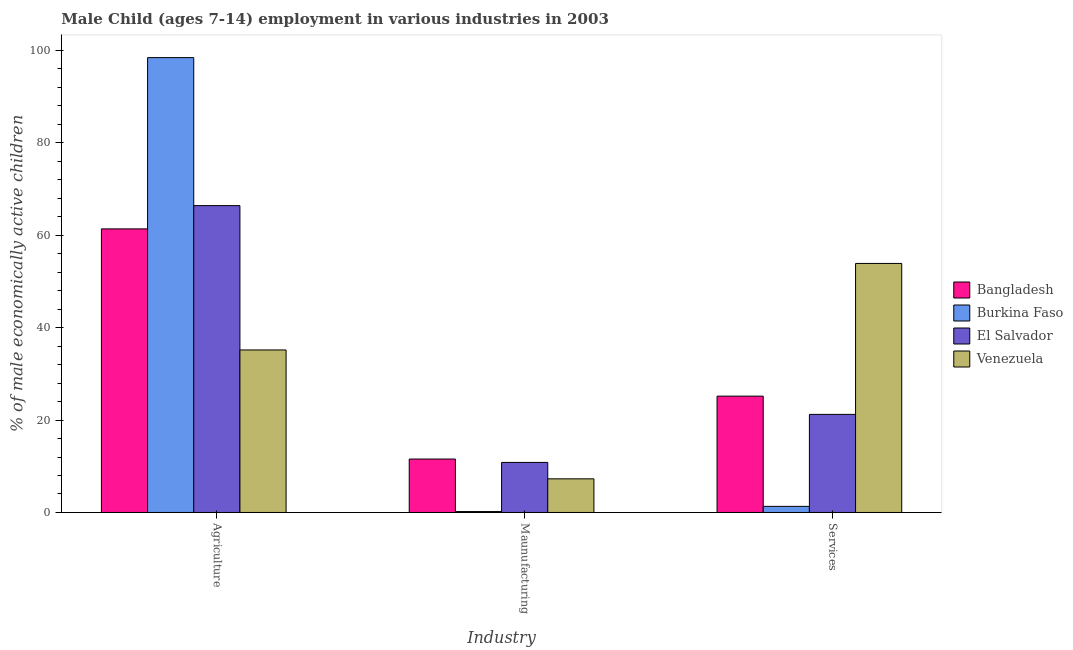How many different coloured bars are there?
Offer a very short reply. 4. Are the number of bars per tick equal to the number of legend labels?
Provide a succinct answer. Yes. Are the number of bars on each tick of the X-axis equal?
Provide a succinct answer. Yes. What is the label of the 3rd group of bars from the left?
Make the answer very short. Services. What is the percentage of economically active children in manufacturing in El Salvador?
Your answer should be compact. 10.83. Across all countries, what is the maximum percentage of economically active children in services?
Keep it short and to the point. 53.87. Across all countries, what is the minimum percentage of economically active children in agriculture?
Offer a terse response. 35.16. In which country was the percentage of economically active children in agriculture maximum?
Your answer should be very brief. Burkina Faso. In which country was the percentage of economically active children in manufacturing minimum?
Ensure brevity in your answer.  Burkina Faso. What is the total percentage of economically active children in agriculture in the graph?
Make the answer very short. 261.29. What is the difference between the percentage of economically active children in manufacturing in Burkina Faso and that in Bangladesh?
Make the answer very short. -11.36. What is the difference between the percentage of economically active children in services in Bangladesh and the percentage of economically active children in manufacturing in Burkina Faso?
Ensure brevity in your answer.  24.97. What is the average percentage of economically active children in manufacturing per country?
Offer a very short reply. 7.47. What is the difference between the percentage of economically active children in agriculture and percentage of economically active children in services in Burkina Faso?
Give a very brief answer. 97.08. What is the ratio of the percentage of economically active children in manufacturing in Venezuela to that in El Salvador?
Give a very brief answer. 0.67. Is the difference between the percentage of economically active children in services in El Salvador and Venezuela greater than the difference between the percentage of economically active children in agriculture in El Salvador and Venezuela?
Offer a very short reply. No. What is the difference between the highest and the second highest percentage of economically active children in services?
Ensure brevity in your answer.  28.7. What is the difference between the highest and the lowest percentage of economically active children in manufacturing?
Offer a very short reply. 11.36. In how many countries, is the percentage of economically active children in services greater than the average percentage of economically active children in services taken over all countries?
Ensure brevity in your answer.  1. What does the 2nd bar from the right in Agriculture represents?
Ensure brevity in your answer.  El Salvador. Are all the bars in the graph horizontal?
Your response must be concise. No. How many countries are there in the graph?
Your answer should be very brief. 4. Are the values on the major ticks of Y-axis written in scientific E-notation?
Give a very brief answer. No. Does the graph contain grids?
Ensure brevity in your answer.  No. Where does the legend appear in the graph?
Make the answer very short. Center right. How many legend labels are there?
Offer a very short reply. 4. What is the title of the graph?
Provide a short and direct response. Male Child (ages 7-14) employment in various industries in 2003. What is the label or title of the X-axis?
Give a very brief answer. Industry. What is the label or title of the Y-axis?
Offer a very short reply. % of male economically active children. What is the % of male economically active children in Bangladesh in Agriculture?
Offer a terse response. 61.35. What is the % of male economically active children of Burkina Faso in Agriculture?
Your answer should be compact. 98.4. What is the % of male economically active children of El Salvador in Agriculture?
Offer a very short reply. 66.38. What is the % of male economically active children of Venezuela in Agriculture?
Keep it short and to the point. 35.16. What is the % of male economically active children of Bangladesh in Maunufacturing?
Provide a short and direct response. 11.56. What is the % of male economically active children in Burkina Faso in Maunufacturing?
Give a very brief answer. 0.2. What is the % of male economically active children of El Salvador in Maunufacturing?
Your answer should be very brief. 10.83. What is the % of male economically active children of Venezuela in Maunufacturing?
Give a very brief answer. 7.28. What is the % of male economically active children in Bangladesh in Services?
Keep it short and to the point. 25.17. What is the % of male economically active children of Burkina Faso in Services?
Provide a succinct answer. 1.32. What is the % of male economically active children of El Salvador in Services?
Offer a very short reply. 21.22. What is the % of male economically active children in Venezuela in Services?
Offer a very short reply. 53.87. Across all Industry, what is the maximum % of male economically active children of Bangladesh?
Provide a succinct answer. 61.35. Across all Industry, what is the maximum % of male economically active children of Burkina Faso?
Provide a short and direct response. 98.4. Across all Industry, what is the maximum % of male economically active children in El Salvador?
Ensure brevity in your answer.  66.38. Across all Industry, what is the maximum % of male economically active children of Venezuela?
Your response must be concise. 53.87. Across all Industry, what is the minimum % of male economically active children in Bangladesh?
Your response must be concise. 11.56. Across all Industry, what is the minimum % of male economically active children of El Salvador?
Offer a very short reply. 10.83. Across all Industry, what is the minimum % of male economically active children in Venezuela?
Provide a succinct answer. 7.28. What is the total % of male economically active children in Bangladesh in the graph?
Offer a very short reply. 98.08. What is the total % of male economically active children of Burkina Faso in the graph?
Make the answer very short. 99.92. What is the total % of male economically active children in El Salvador in the graph?
Provide a short and direct response. 98.44. What is the total % of male economically active children in Venezuela in the graph?
Ensure brevity in your answer.  96.31. What is the difference between the % of male economically active children of Bangladesh in Agriculture and that in Maunufacturing?
Ensure brevity in your answer.  49.79. What is the difference between the % of male economically active children in Burkina Faso in Agriculture and that in Maunufacturing?
Keep it short and to the point. 98.2. What is the difference between the % of male economically active children of El Salvador in Agriculture and that in Maunufacturing?
Ensure brevity in your answer.  55.55. What is the difference between the % of male economically active children of Venezuela in Agriculture and that in Maunufacturing?
Provide a succinct answer. 27.88. What is the difference between the % of male economically active children of Bangladesh in Agriculture and that in Services?
Provide a short and direct response. 36.18. What is the difference between the % of male economically active children in Burkina Faso in Agriculture and that in Services?
Provide a short and direct response. 97.08. What is the difference between the % of male economically active children in El Salvador in Agriculture and that in Services?
Offer a terse response. 45.16. What is the difference between the % of male economically active children in Venezuela in Agriculture and that in Services?
Provide a succinct answer. -18.72. What is the difference between the % of male economically active children in Bangladesh in Maunufacturing and that in Services?
Ensure brevity in your answer.  -13.61. What is the difference between the % of male economically active children of Burkina Faso in Maunufacturing and that in Services?
Ensure brevity in your answer.  -1.12. What is the difference between the % of male economically active children of El Salvador in Maunufacturing and that in Services?
Make the answer very short. -10.39. What is the difference between the % of male economically active children in Venezuela in Maunufacturing and that in Services?
Ensure brevity in your answer.  -46.6. What is the difference between the % of male economically active children in Bangladesh in Agriculture and the % of male economically active children in Burkina Faso in Maunufacturing?
Your response must be concise. 61.15. What is the difference between the % of male economically active children of Bangladesh in Agriculture and the % of male economically active children of El Salvador in Maunufacturing?
Offer a terse response. 50.52. What is the difference between the % of male economically active children in Bangladesh in Agriculture and the % of male economically active children in Venezuela in Maunufacturing?
Offer a terse response. 54.07. What is the difference between the % of male economically active children of Burkina Faso in Agriculture and the % of male economically active children of El Salvador in Maunufacturing?
Give a very brief answer. 87.57. What is the difference between the % of male economically active children of Burkina Faso in Agriculture and the % of male economically active children of Venezuela in Maunufacturing?
Offer a very short reply. 91.12. What is the difference between the % of male economically active children in El Salvador in Agriculture and the % of male economically active children in Venezuela in Maunufacturing?
Provide a succinct answer. 59.11. What is the difference between the % of male economically active children in Bangladesh in Agriculture and the % of male economically active children in Burkina Faso in Services?
Give a very brief answer. 60.03. What is the difference between the % of male economically active children of Bangladesh in Agriculture and the % of male economically active children of El Salvador in Services?
Make the answer very short. 40.13. What is the difference between the % of male economically active children in Bangladesh in Agriculture and the % of male economically active children in Venezuela in Services?
Keep it short and to the point. 7.48. What is the difference between the % of male economically active children of Burkina Faso in Agriculture and the % of male economically active children of El Salvador in Services?
Provide a short and direct response. 77.18. What is the difference between the % of male economically active children of Burkina Faso in Agriculture and the % of male economically active children of Venezuela in Services?
Ensure brevity in your answer.  44.53. What is the difference between the % of male economically active children in El Salvador in Agriculture and the % of male economically active children in Venezuela in Services?
Offer a very short reply. 12.51. What is the difference between the % of male economically active children of Bangladesh in Maunufacturing and the % of male economically active children of Burkina Faso in Services?
Make the answer very short. 10.24. What is the difference between the % of male economically active children in Bangladesh in Maunufacturing and the % of male economically active children in El Salvador in Services?
Make the answer very short. -9.66. What is the difference between the % of male economically active children of Bangladesh in Maunufacturing and the % of male economically active children of Venezuela in Services?
Keep it short and to the point. -42.31. What is the difference between the % of male economically active children of Burkina Faso in Maunufacturing and the % of male economically active children of El Salvador in Services?
Your answer should be very brief. -21.02. What is the difference between the % of male economically active children in Burkina Faso in Maunufacturing and the % of male economically active children in Venezuela in Services?
Make the answer very short. -53.67. What is the difference between the % of male economically active children of El Salvador in Maunufacturing and the % of male economically active children of Venezuela in Services?
Your answer should be compact. -43.05. What is the average % of male economically active children of Bangladesh per Industry?
Provide a succinct answer. 32.69. What is the average % of male economically active children in Burkina Faso per Industry?
Make the answer very short. 33.31. What is the average % of male economically active children of El Salvador per Industry?
Offer a very short reply. 32.81. What is the average % of male economically active children in Venezuela per Industry?
Provide a short and direct response. 32.1. What is the difference between the % of male economically active children in Bangladesh and % of male economically active children in Burkina Faso in Agriculture?
Your response must be concise. -37.05. What is the difference between the % of male economically active children of Bangladesh and % of male economically active children of El Salvador in Agriculture?
Your answer should be compact. -5.03. What is the difference between the % of male economically active children in Bangladesh and % of male economically active children in Venezuela in Agriculture?
Your answer should be compact. 26.19. What is the difference between the % of male economically active children of Burkina Faso and % of male economically active children of El Salvador in Agriculture?
Your answer should be very brief. 32.02. What is the difference between the % of male economically active children in Burkina Faso and % of male economically active children in Venezuela in Agriculture?
Ensure brevity in your answer.  63.24. What is the difference between the % of male economically active children in El Salvador and % of male economically active children in Venezuela in Agriculture?
Ensure brevity in your answer.  31.23. What is the difference between the % of male economically active children in Bangladesh and % of male economically active children in Burkina Faso in Maunufacturing?
Offer a very short reply. 11.36. What is the difference between the % of male economically active children of Bangladesh and % of male economically active children of El Salvador in Maunufacturing?
Make the answer very short. 0.73. What is the difference between the % of male economically active children in Bangladesh and % of male economically active children in Venezuela in Maunufacturing?
Make the answer very short. 4.28. What is the difference between the % of male economically active children in Burkina Faso and % of male economically active children in El Salvador in Maunufacturing?
Make the answer very short. -10.63. What is the difference between the % of male economically active children of Burkina Faso and % of male economically active children of Venezuela in Maunufacturing?
Give a very brief answer. -7.08. What is the difference between the % of male economically active children of El Salvador and % of male economically active children of Venezuela in Maunufacturing?
Your response must be concise. 3.55. What is the difference between the % of male economically active children in Bangladesh and % of male economically active children in Burkina Faso in Services?
Offer a terse response. 23.85. What is the difference between the % of male economically active children in Bangladesh and % of male economically active children in El Salvador in Services?
Your answer should be very brief. 3.95. What is the difference between the % of male economically active children of Bangladesh and % of male economically active children of Venezuela in Services?
Keep it short and to the point. -28.7. What is the difference between the % of male economically active children of Burkina Faso and % of male economically active children of El Salvador in Services?
Your answer should be very brief. -19.9. What is the difference between the % of male economically active children in Burkina Faso and % of male economically active children in Venezuela in Services?
Give a very brief answer. -52.55. What is the difference between the % of male economically active children of El Salvador and % of male economically active children of Venezuela in Services?
Your response must be concise. -32.65. What is the ratio of the % of male economically active children of Bangladesh in Agriculture to that in Maunufacturing?
Ensure brevity in your answer.  5.31. What is the ratio of the % of male economically active children in Burkina Faso in Agriculture to that in Maunufacturing?
Offer a very short reply. 492. What is the ratio of the % of male economically active children of El Salvador in Agriculture to that in Maunufacturing?
Offer a very short reply. 6.13. What is the ratio of the % of male economically active children in Venezuela in Agriculture to that in Maunufacturing?
Offer a terse response. 4.83. What is the ratio of the % of male economically active children of Bangladesh in Agriculture to that in Services?
Your answer should be compact. 2.44. What is the ratio of the % of male economically active children in Burkina Faso in Agriculture to that in Services?
Your response must be concise. 74.5. What is the ratio of the % of male economically active children of El Salvador in Agriculture to that in Services?
Ensure brevity in your answer.  3.13. What is the ratio of the % of male economically active children of Venezuela in Agriculture to that in Services?
Provide a succinct answer. 0.65. What is the ratio of the % of male economically active children in Bangladesh in Maunufacturing to that in Services?
Offer a terse response. 0.46. What is the ratio of the % of male economically active children in Burkina Faso in Maunufacturing to that in Services?
Ensure brevity in your answer.  0.15. What is the ratio of the % of male economically active children of El Salvador in Maunufacturing to that in Services?
Your response must be concise. 0.51. What is the ratio of the % of male economically active children in Venezuela in Maunufacturing to that in Services?
Make the answer very short. 0.14. What is the difference between the highest and the second highest % of male economically active children in Bangladesh?
Ensure brevity in your answer.  36.18. What is the difference between the highest and the second highest % of male economically active children in Burkina Faso?
Offer a terse response. 97.08. What is the difference between the highest and the second highest % of male economically active children of El Salvador?
Your answer should be compact. 45.16. What is the difference between the highest and the second highest % of male economically active children of Venezuela?
Make the answer very short. 18.72. What is the difference between the highest and the lowest % of male economically active children of Bangladesh?
Make the answer very short. 49.79. What is the difference between the highest and the lowest % of male economically active children of Burkina Faso?
Your answer should be very brief. 98.2. What is the difference between the highest and the lowest % of male economically active children of El Salvador?
Give a very brief answer. 55.55. What is the difference between the highest and the lowest % of male economically active children in Venezuela?
Your answer should be compact. 46.6. 